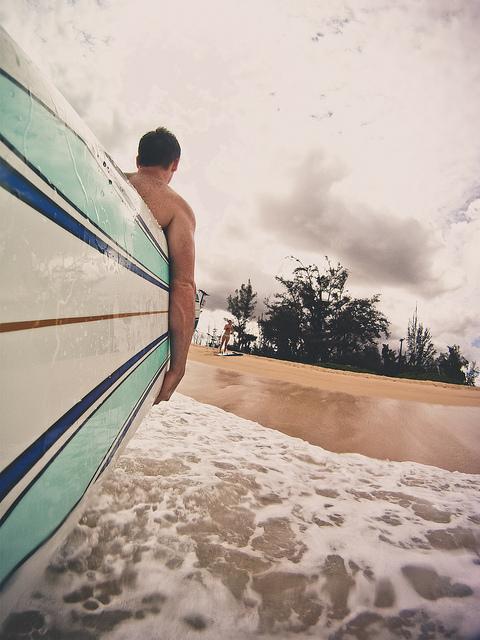Is the man wearing a hat?
Be succinct. No. How many non-yellow stripes are on the board that he's holding?
Keep it brief. 6. What is the person carrying?
Keep it brief. Surfboard. Is this person able to stay above water?
Concise answer only. Yes. 